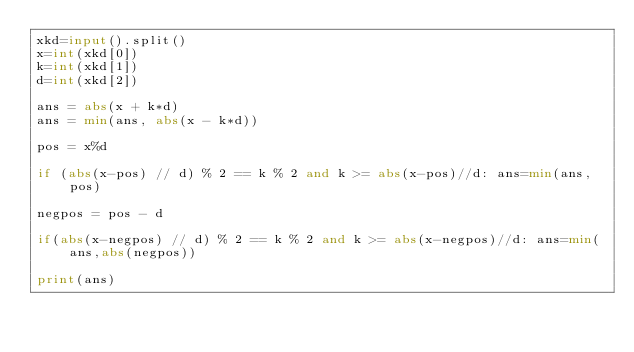<code> <loc_0><loc_0><loc_500><loc_500><_Python_>xkd=input().split()
x=int(xkd[0])
k=int(xkd[1])
d=int(xkd[2])

ans = abs(x + k*d)
ans = min(ans, abs(x - k*d))

pos = x%d

if (abs(x-pos) // d) % 2 == k % 2 and k >= abs(x-pos)//d: ans=min(ans, pos)

negpos = pos - d

if(abs(x-negpos) // d) % 2 == k % 2 and k >= abs(x-negpos)//d: ans=min(ans,abs(negpos))

print(ans)</code> 